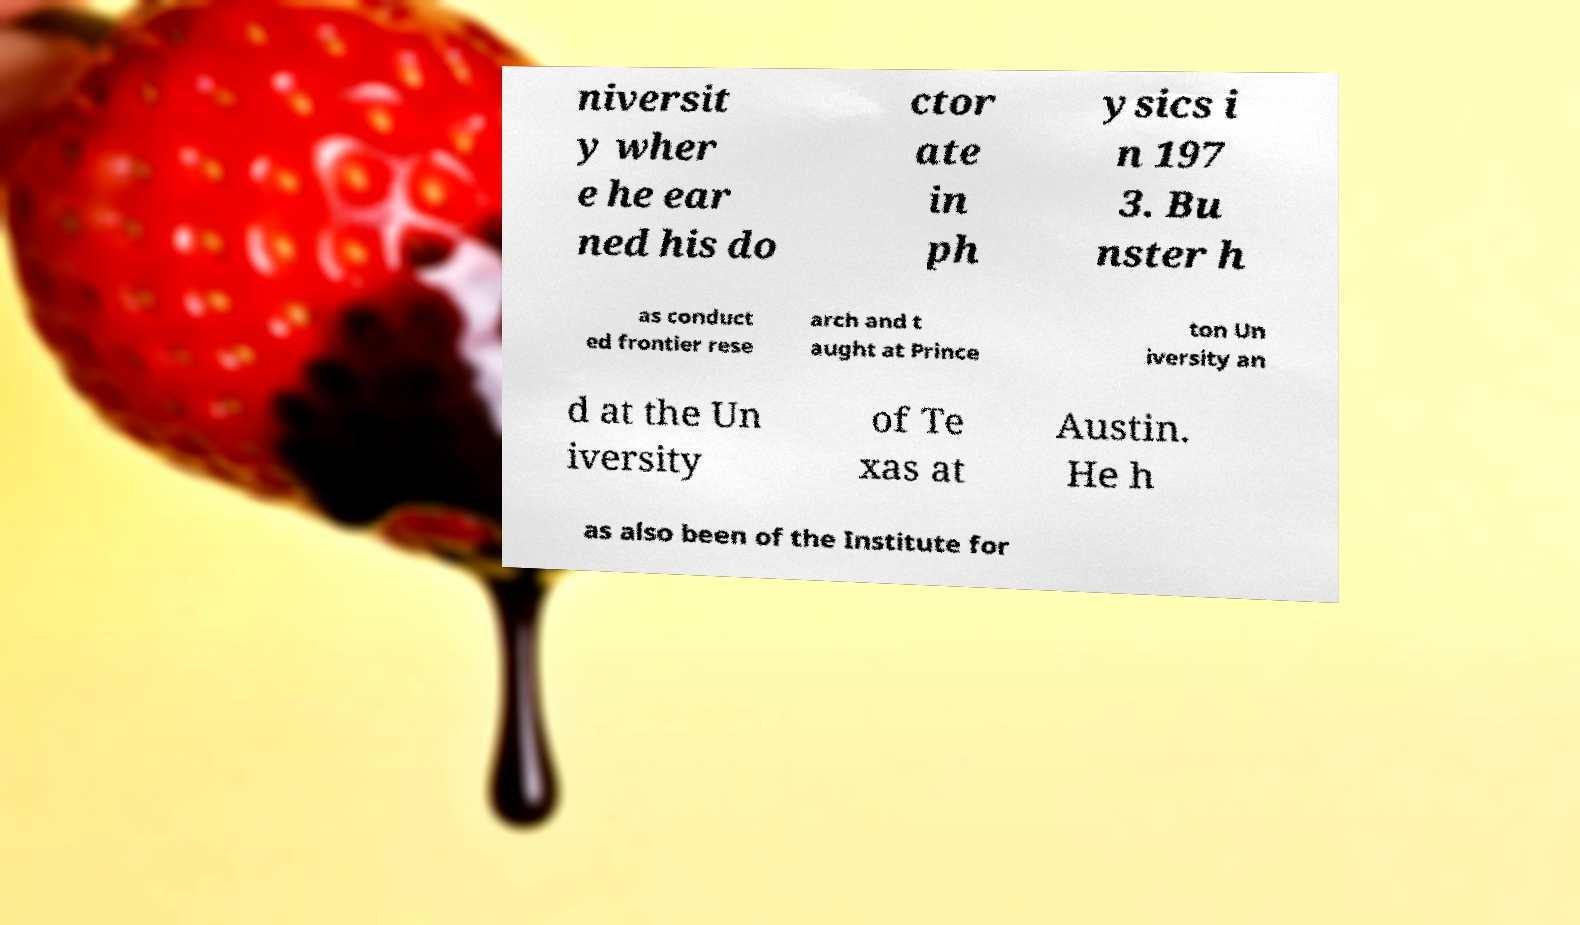Could you extract and type out the text from this image? niversit y wher e he ear ned his do ctor ate in ph ysics i n 197 3. Bu nster h as conduct ed frontier rese arch and t aught at Prince ton Un iversity an d at the Un iversity of Te xas at Austin. He h as also been of the Institute for 